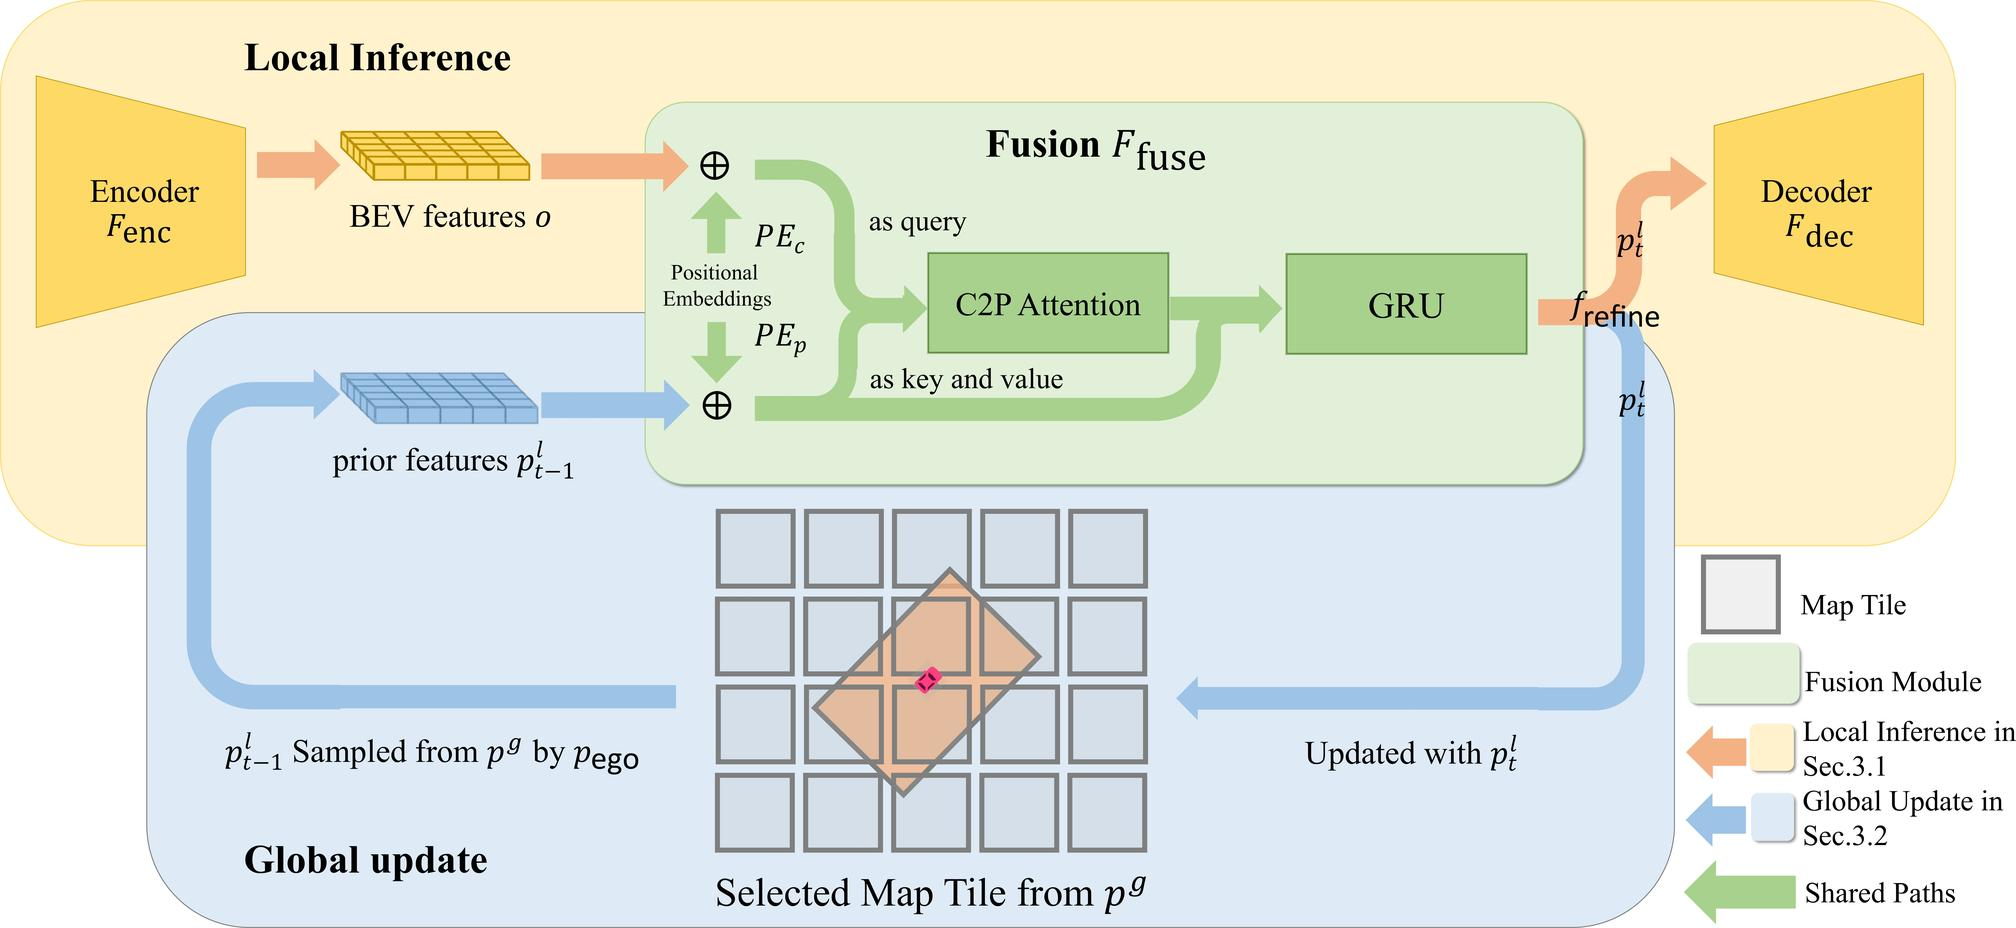What is the role of the GRU component in the given figure? The GRU (Gated Recurrent Unit) in the diagram plays a crucial role within the fusion module by integrating temporal information. This makes it key in managing the sequence of features over time. Essentially, the GRU receives the output from the C2P (Camera to Plan) Attention module, which processes positional embeddings and BEV (Bird's Eye View) features, and then refines these inputs to produce updated predictive features. This temporal synthesis allows for more accurate and dynamic updates to the system's understanding, enhancing the overall decision-making process in applications like automated navigation systems. 